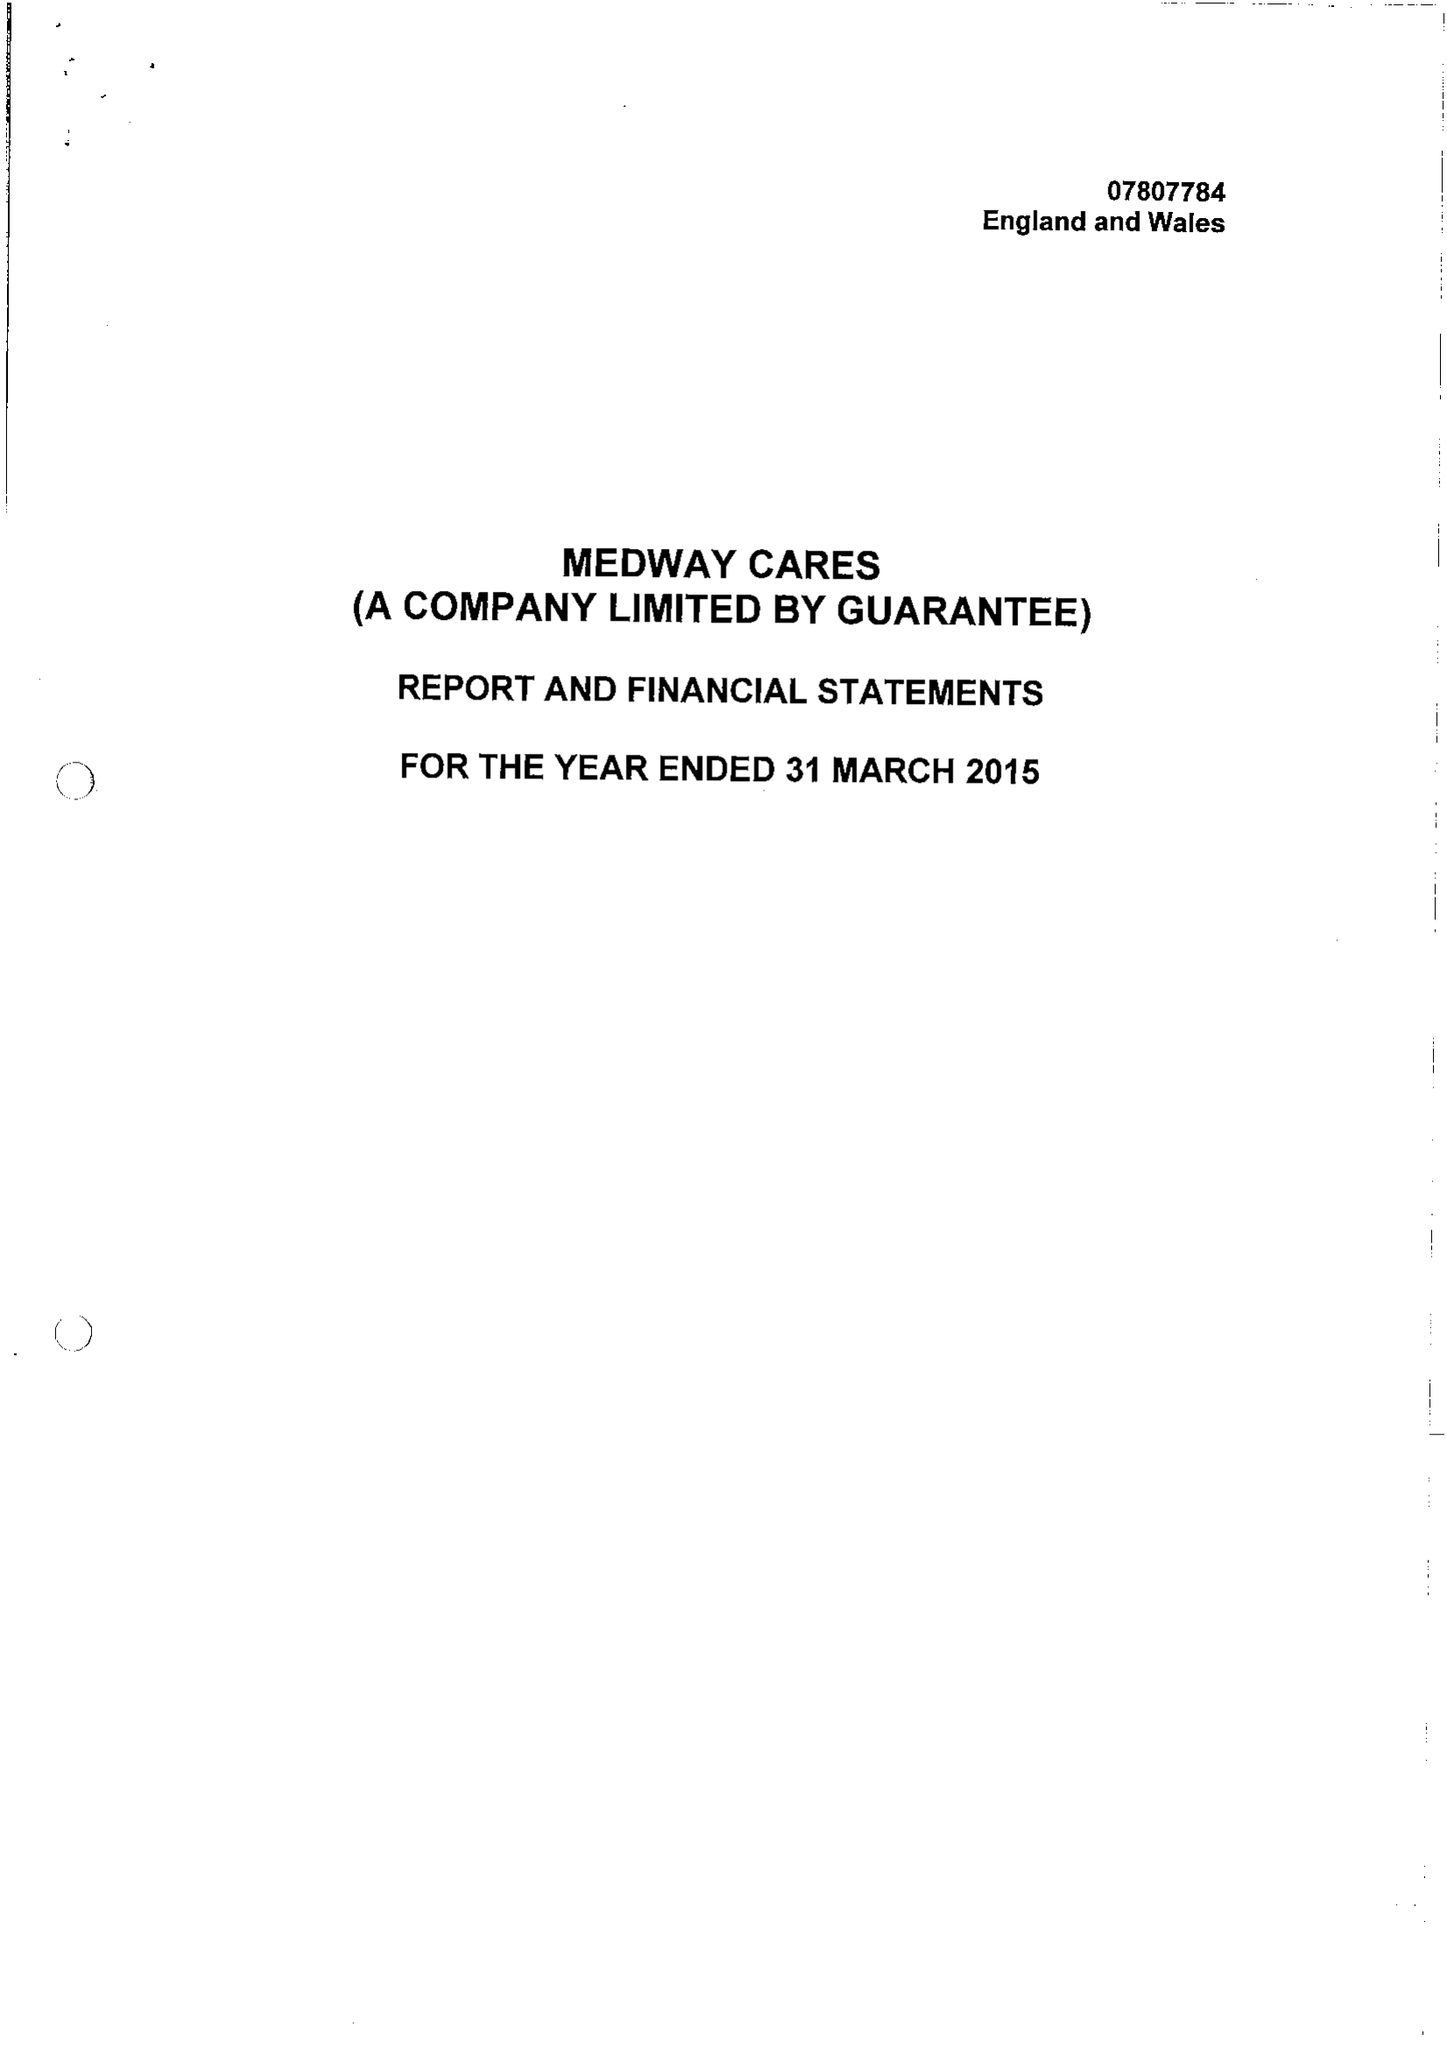What is the value for the income_annually_in_british_pounds?
Answer the question using a single word or phrase. 71464.00 